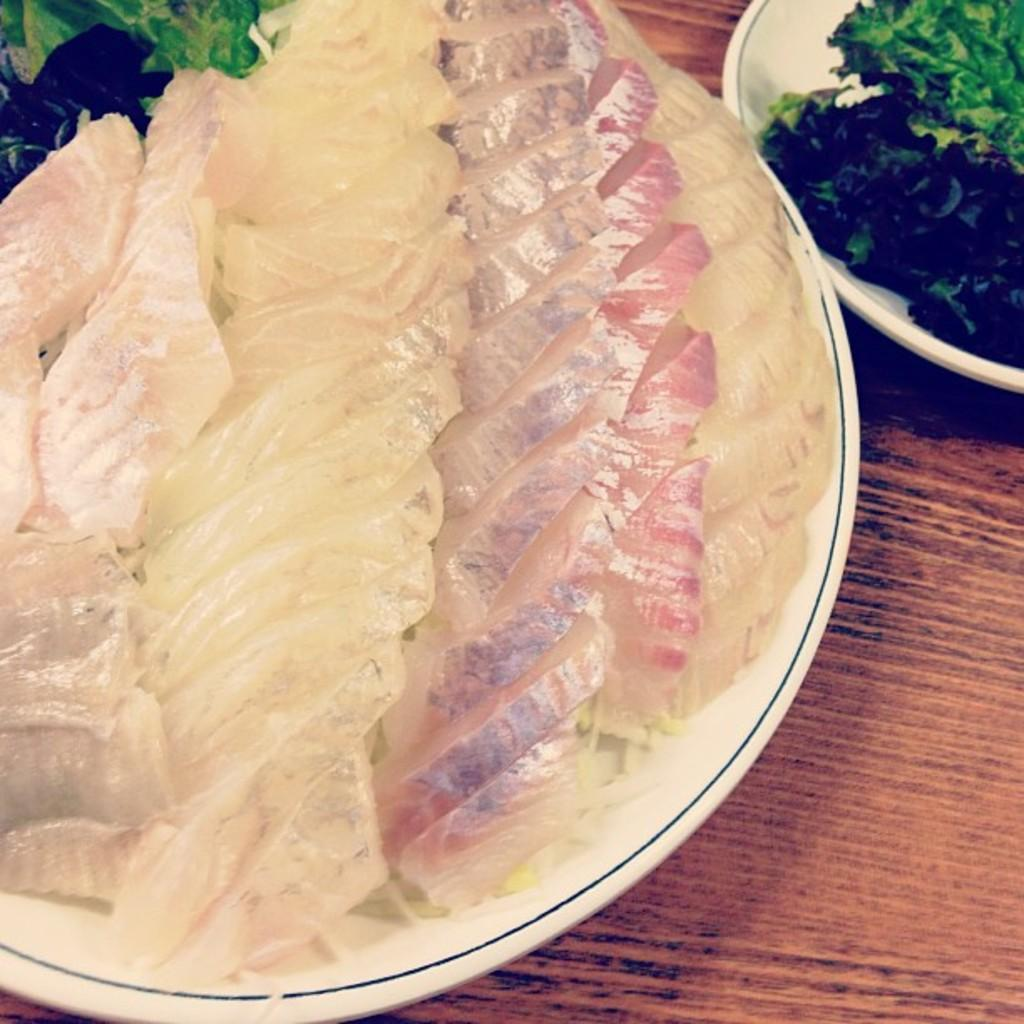What type of dishware can be seen in the image? There are white plates in the image. What is on the plates? Different types of food are present on the plates. Can you describe the colors of the food? The colors of the food include cream and green. What type of prison is advertised on the page in the image? There is no prison or page present in the image; it only features white plates with food on them. 